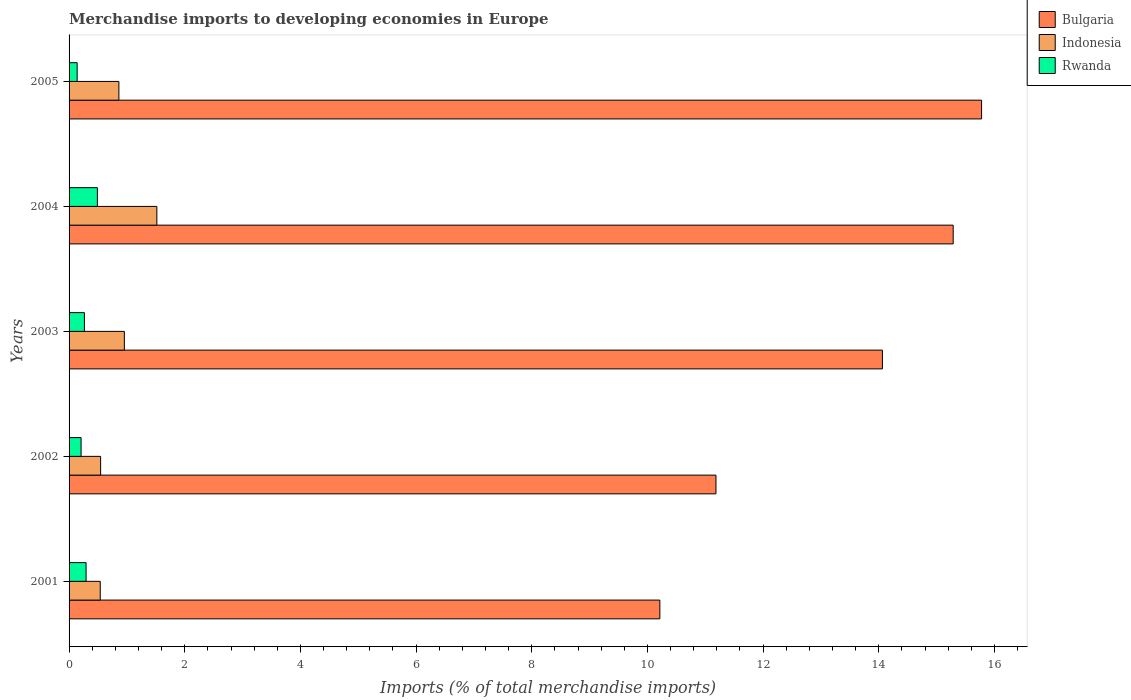How many groups of bars are there?
Your answer should be very brief. 5. Are the number of bars on each tick of the Y-axis equal?
Offer a very short reply. Yes. How many bars are there on the 2nd tick from the top?
Offer a very short reply. 3. What is the label of the 2nd group of bars from the top?
Your answer should be very brief. 2004. In how many cases, is the number of bars for a given year not equal to the number of legend labels?
Offer a very short reply. 0. What is the percentage total merchandise imports in Rwanda in 2001?
Make the answer very short. 0.29. Across all years, what is the maximum percentage total merchandise imports in Rwanda?
Keep it short and to the point. 0.49. Across all years, what is the minimum percentage total merchandise imports in Rwanda?
Provide a succinct answer. 0.14. In which year was the percentage total merchandise imports in Indonesia maximum?
Ensure brevity in your answer.  2004. What is the total percentage total merchandise imports in Rwanda in the graph?
Your response must be concise. 1.4. What is the difference between the percentage total merchandise imports in Bulgaria in 2003 and that in 2005?
Provide a succinct answer. -1.71. What is the difference between the percentage total merchandise imports in Rwanda in 2005 and the percentage total merchandise imports in Indonesia in 2001?
Ensure brevity in your answer.  -0.4. What is the average percentage total merchandise imports in Bulgaria per year?
Make the answer very short. 13.3. In the year 2005, what is the difference between the percentage total merchandise imports in Rwanda and percentage total merchandise imports in Bulgaria?
Keep it short and to the point. -15.64. In how many years, is the percentage total merchandise imports in Bulgaria greater than 4 %?
Offer a terse response. 5. What is the ratio of the percentage total merchandise imports in Bulgaria in 2003 to that in 2005?
Offer a terse response. 0.89. Is the percentage total merchandise imports in Indonesia in 2004 less than that in 2005?
Ensure brevity in your answer.  No. Is the difference between the percentage total merchandise imports in Rwanda in 2002 and 2005 greater than the difference between the percentage total merchandise imports in Bulgaria in 2002 and 2005?
Ensure brevity in your answer.  Yes. What is the difference between the highest and the second highest percentage total merchandise imports in Rwanda?
Your response must be concise. 0.2. What is the difference between the highest and the lowest percentage total merchandise imports in Bulgaria?
Ensure brevity in your answer.  5.56. What does the 2nd bar from the bottom in 2001 represents?
Make the answer very short. Indonesia. Is it the case that in every year, the sum of the percentage total merchandise imports in Rwanda and percentage total merchandise imports in Bulgaria is greater than the percentage total merchandise imports in Indonesia?
Offer a terse response. Yes. How many bars are there?
Offer a terse response. 15. Are all the bars in the graph horizontal?
Offer a terse response. Yes. Does the graph contain grids?
Provide a succinct answer. No. How many legend labels are there?
Ensure brevity in your answer.  3. What is the title of the graph?
Keep it short and to the point. Merchandise imports to developing economies in Europe. What is the label or title of the X-axis?
Keep it short and to the point. Imports (% of total merchandise imports). What is the Imports (% of total merchandise imports) of Bulgaria in 2001?
Keep it short and to the point. 10.21. What is the Imports (% of total merchandise imports) in Indonesia in 2001?
Your response must be concise. 0.54. What is the Imports (% of total merchandise imports) in Rwanda in 2001?
Offer a terse response. 0.29. What is the Imports (% of total merchandise imports) of Bulgaria in 2002?
Your answer should be compact. 11.18. What is the Imports (% of total merchandise imports) of Indonesia in 2002?
Your answer should be very brief. 0.55. What is the Imports (% of total merchandise imports) of Rwanda in 2002?
Keep it short and to the point. 0.21. What is the Imports (% of total merchandise imports) in Bulgaria in 2003?
Give a very brief answer. 14.06. What is the Imports (% of total merchandise imports) in Indonesia in 2003?
Offer a very short reply. 0.96. What is the Imports (% of total merchandise imports) in Rwanda in 2003?
Your answer should be compact. 0.27. What is the Imports (% of total merchandise imports) in Bulgaria in 2004?
Your answer should be compact. 15.29. What is the Imports (% of total merchandise imports) of Indonesia in 2004?
Keep it short and to the point. 1.52. What is the Imports (% of total merchandise imports) in Rwanda in 2004?
Offer a terse response. 0.49. What is the Imports (% of total merchandise imports) of Bulgaria in 2005?
Make the answer very short. 15.78. What is the Imports (% of total merchandise imports) in Indonesia in 2005?
Your answer should be very brief. 0.86. What is the Imports (% of total merchandise imports) in Rwanda in 2005?
Your answer should be very brief. 0.14. Across all years, what is the maximum Imports (% of total merchandise imports) in Bulgaria?
Provide a short and direct response. 15.78. Across all years, what is the maximum Imports (% of total merchandise imports) in Indonesia?
Give a very brief answer. 1.52. Across all years, what is the maximum Imports (% of total merchandise imports) of Rwanda?
Provide a short and direct response. 0.49. Across all years, what is the minimum Imports (% of total merchandise imports) in Bulgaria?
Provide a short and direct response. 10.21. Across all years, what is the minimum Imports (% of total merchandise imports) of Indonesia?
Offer a terse response. 0.54. Across all years, what is the minimum Imports (% of total merchandise imports) in Rwanda?
Provide a succinct answer. 0.14. What is the total Imports (% of total merchandise imports) of Bulgaria in the graph?
Provide a succinct answer. 66.52. What is the total Imports (% of total merchandise imports) in Indonesia in the graph?
Provide a succinct answer. 4.42. What is the total Imports (% of total merchandise imports) of Rwanda in the graph?
Give a very brief answer. 1.4. What is the difference between the Imports (% of total merchandise imports) in Bulgaria in 2001 and that in 2002?
Your answer should be very brief. -0.97. What is the difference between the Imports (% of total merchandise imports) of Indonesia in 2001 and that in 2002?
Give a very brief answer. -0.01. What is the difference between the Imports (% of total merchandise imports) in Rwanda in 2001 and that in 2002?
Keep it short and to the point. 0.09. What is the difference between the Imports (% of total merchandise imports) in Bulgaria in 2001 and that in 2003?
Give a very brief answer. -3.85. What is the difference between the Imports (% of total merchandise imports) in Indonesia in 2001 and that in 2003?
Ensure brevity in your answer.  -0.42. What is the difference between the Imports (% of total merchandise imports) of Rwanda in 2001 and that in 2003?
Provide a short and direct response. 0.03. What is the difference between the Imports (% of total merchandise imports) in Bulgaria in 2001 and that in 2004?
Provide a succinct answer. -5.07. What is the difference between the Imports (% of total merchandise imports) of Indonesia in 2001 and that in 2004?
Your answer should be compact. -0.98. What is the difference between the Imports (% of total merchandise imports) of Rwanda in 2001 and that in 2004?
Your response must be concise. -0.2. What is the difference between the Imports (% of total merchandise imports) in Bulgaria in 2001 and that in 2005?
Offer a very short reply. -5.56. What is the difference between the Imports (% of total merchandise imports) of Indonesia in 2001 and that in 2005?
Ensure brevity in your answer.  -0.32. What is the difference between the Imports (% of total merchandise imports) of Rwanda in 2001 and that in 2005?
Your answer should be compact. 0.15. What is the difference between the Imports (% of total merchandise imports) in Bulgaria in 2002 and that in 2003?
Keep it short and to the point. -2.88. What is the difference between the Imports (% of total merchandise imports) of Indonesia in 2002 and that in 2003?
Provide a succinct answer. -0.41. What is the difference between the Imports (% of total merchandise imports) in Rwanda in 2002 and that in 2003?
Give a very brief answer. -0.06. What is the difference between the Imports (% of total merchandise imports) in Bulgaria in 2002 and that in 2004?
Your answer should be compact. -4.1. What is the difference between the Imports (% of total merchandise imports) in Indonesia in 2002 and that in 2004?
Your response must be concise. -0.97. What is the difference between the Imports (% of total merchandise imports) of Rwanda in 2002 and that in 2004?
Offer a terse response. -0.28. What is the difference between the Imports (% of total merchandise imports) of Bulgaria in 2002 and that in 2005?
Your answer should be compact. -4.59. What is the difference between the Imports (% of total merchandise imports) of Indonesia in 2002 and that in 2005?
Make the answer very short. -0.32. What is the difference between the Imports (% of total merchandise imports) of Rwanda in 2002 and that in 2005?
Your answer should be compact. 0.07. What is the difference between the Imports (% of total merchandise imports) in Bulgaria in 2003 and that in 2004?
Ensure brevity in your answer.  -1.22. What is the difference between the Imports (% of total merchandise imports) of Indonesia in 2003 and that in 2004?
Make the answer very short. -0.56. What is the difference between the Imports (% of total merchandise imports) of Rwanda in 2003 and that in 2004?
Your answer should be compact. -0.22. What is the difference between the Imports (% of total merchandise imports) of Bulgaria in 2003 and that in 2005?
Provide a short and direct response. -1.71. What is the difference between the Imports (% of total merchandise imports) of Indonesia in 2003 and that in 2005?
Make the answer very short. 0.09. What is the difference between the Imports (% of total merchandise imports) in Rwanda in 2003 and that in 2005?
Offer a very short reply. 0.13. What is the difference between the Imports (% of total merchandise imports) of Bulgaria in 2004 and that in 2005?
Give a very brief answer. -0.49. What is the difference between the Imports (% of total merchandise imports) of Indonesia in 2004 and that in 2005?
Ensure brevity in your answer.  0.66. What is the difference between the Imports (% of total merchandise imports) in Rwanda in 2004 and that in 2005?
Keep it short and to the point. 0.35. What is the difference between the Imports (% of total merchandise imports) of Bulgaria in 2001 and the Imports (% of total merchandise imports) of Indonesia in 2002?
Keep it short and to the point. 9.67. What is the difference between the Imports (% of total merchandise imports) in Bulgaria in 2001 and the Imports (% of total merchandise imports) in Rwanda in 2002?
Ensure brevity in your answer.  10.01. What is the difference between the Imports (% of total merchandise imports) of Indonesia in 2001 and the Imports (% of total merchandise imports) of Rwanda in 2002?
Offer a very short reply. 0.33. What is the difference between the Imports (% of total merchandise imports) of Bulgaria in 2001 and the Imports (% of total merchandise imports) of Indonesia in 2003?
Ensure brevity in your answer.  9.26. What is the difference between the Imports (% of total merchandise imports) of Bulgaria in 2001 and the Imports (% of total merchandise imports) of Rwanda in 2003?
Keep it short and to the point. 9.95. What is the difference between the Imports (% of total merchandise imports) in Indonesia in 2001 and the Imports (% of total merchandise imports) in Rwanda in 2003?
Your answer should be compact. 0.27. What is the difference between the Imports (% of total merchandise imports) of Bulgaria in 2001 and the Imports (% of total merchandise imports) of Indonesia in 2004?
Your answer should be very brief. 8.7. What is the difference between the Imports (% of total merchandise imports) of Bulgaria in 2001 and the Imports (% of total merchandise imports) of Rwanda in 2004?
Provide a succinct answer. 9.72. What is the difference between the Imports (% of total merchandise imports) of Indonesia in 2001 and the Imports (% of total merchandise imports) of Rwanda in 2004?
Make the answer very short. 0.05. What is the difference between the Imports (% of total merchandise imports) of Bulgaria in 2001 and the Imports (% of total merchandise imports) of Indonesia in 2005?
Give a very brief answer. 9.35. What is the difference between the Imports (% of total merchandise imports) of Bulgaria in 2001 and the Imports (% of total merchandise imports) of Rwanda in 2005?
Your answer should be very brief. 10.07. What is the difference between the Imports (% of total merchandise imports) of Indonesia in 2001 and the Imports (% of total merchandise imports) of Rwanda in 2005?
Ensure brevity in your answer.  0.4. What is the difference between the Imports (% of total merchandise imports) in Bulgaria in 2002 and the Imports (% of total merchandise imports) in Indonesia in 2003?
Your answer should be very brief. 10.23. What is the difference between the Imports (% of total merchandise imports) of Bulgaria in 2002 and the Imports (% of total merchandise imports) of Rwanda in 2003?
Provide a succinct answer. 10.92. What is the difference between the Imports (% of total merchandise imports) in Indonesia in 2002 and the Imports (% of total merchandise imports) in Rwanda in 2003?
Your answer should be compact. 0.28. What is the difference between the Imports (% of total merchandise imports) of Bulgaria in 2002 and the Imports (% of total merchandise imports) of Indonesia in 2004?
Offer a terse response. 9.67. What is the difference between the Imports (% of total merchandise imports) in Bulgaria in 2002 and the Imports (% of total merchandise imports) in Rwanda in 2004?
Your answer should be compact. 10.7. What is the difference between the Imports (% of total merchandise imports) in Indonesia in 2002 and the Imports (% of total merchandise imports) in Rwanda in 2004?
Make the answer very short. 0.06. What is the difference between the Imports (% of total merchandise imports) in Bulgaria in 2002 and the Imports (% of total merchandise imports) in Indonesia in 2005?
Give a very brief answer. 10.32. What is the difference between the Imports (% of total merchandise imports) of Bulgaria in 2002 and the Imports (% of total merchandise imports) of Rwanda in 2005?
Your response must be concise. 11.04. What is the difference between the Imports (% of total merchandise imports) of Indonesia in 2002 and the Imports (% of total merchandise imports) of Rwanda in 2005?
Your answer should be very brief. 0.41. What is the difference between the Imports (% of total merchandise imports) of Bulgaria in 2003 and the Imports (% of total merchandise imports) of Indonesia in 2004?
Your answer should be compact. 12.54. What is the difference between the Imports (% of total merchandise imports) in Bulgaria in 2003 and the Imports (% of total merchandise imports) in Rwanda in 2004?
Ensure brevity in your answer.  13.57. What is the difference between the Imports (% of total merchandise imports) in Indonesia in 2003 and the Imports (% of total merchandise imports) in Rwanda in 2004?
Give a very brief answer. 0.47. What is the difference between the Imports (% of total merchandise imports) in Bulgaria in 2003 and the Imports (% of total merchandise imports) in Indonesia in 2005?
Provide a short and direct response. 13.2. What is the difference between the Imports (% of total merchandise imports) of Bulgaria in 2003 and the Imports (% of total merchandise imports) of Rwanda in 2005?
Your answer should be very brief. 13.92. What is the difference between the Imports (% of total merchandise imports) of Indonesia in 2003 and the Imports (% of total merchandise imports) of Rwanda in 2005?
Make the answer very short. 0.82. What is the difference between the Imports (% of total merchandise imports) of Bulgaria in 2004 and the Imports (% of total merchandise imports) of Indonesia in 2005?
Provide a short and direct response. 14.42. What is the difference between the Imports (% of total merchandise imports) of Bulgaria in 2004 and the Imports (% of total merchandise imports) of Rwanda in 2005?
Ensure brevity in your answer.  15.15. What is the difference between the Imports (% of total merchandise imports) of Indonesia in 2004 and the Imports (% of total merchandise imports) of Rwanda in 2005?
Keep it short and to the point. 1.38. What is the average Imports (% of total merchandise imports) in Bulgaria per year?
Your answer should be very brief. 13.3. What is the average Imports (% of total merchandise imports) in Indonesia per year?
Provide a short and direct response. 0.88. What is the average Imports (% of total merchandise imports) in Rwanda per year?
Your response must be concise. 0.28. In the year 2001, what is the difference between the Imports (% of total merchandise imports) in Bulgaria and Imports (% of total merchandise imports) in Indonesia?
Your answer should be very brief. 9.68. In the year 2001, what is the difference between the Imports (% of total merchandise imports) in Bulgaria and Imports (% of total merchandise imports) in Rwanda?
Offer a very short reply. 9.92. In the year 2001, what is the difference between the Imports (% of total merchandise imports) in Indonesia and Imports (% of total merchandise imports) in Rwanda?
Offer a terse response. 0.24. In the year 2002, what is the difference between the Imports (% of total merchandise imports) in Bulgaria and Imports (% of total merchandise imports) in Indonesia?
Ensure brevity in your answer.  10.64. In the year 2002, what is the difference between the Imports (% of total merchandise imports) of Bulgaria and Imports (% of total merchandise imports) of Rwanda?
Offer a terse response. 10.98. In the year 2002, what is the difference between the Imports (% of total merchandise imports) in Indonesia and Imports (% of total merchandise imports) in Rwanda?
Keep it short and to the point. 0.34. In the year 2003, what is the difference between the Imports (% of total merchandise imports) of Bulgaria and Imports (% of total merchandise imports) of Indonesia?
Keep it short and to the point. 13.11. In the year 2003, what is the difference between the Imports (% of total merchandise imports) of Bulgaria and Imports (% of total merchandise imports) of Rwanda?
Offer a terse response. 13.8. In the year 2003, what is the difference between the Imports (% of total merchandise imports) of Indonesia and Imports (% of total merchandise imports) of Rwanda?
Your answer should be compact. 0.69. In the year 2004, what is the difference between the Imports (% of total merchandise imports) in Bulgaria and Imports (% of total merchandise imports) in Indonesia?
Provide a short and direct response. 13.77. In the year 2004, what is the difference between the Imports (% of total merchandise imports) of Bulgaria and Imports (% of total merchandise imports) of Rwanda?
Offer a terse response. 14.8. In the year 2004, what is the difference between the Imports (% of total merchandise imports) in Indonesia and Imports (% of total merchandise imports) in Rwanda?
Your answer should be very brief. 1.03. In the year 2005, what is the difference between the Imports (% of total merchandise imports) in Bulgaria and Imports (% of total merchandise imports) in Indonesia?
Your answer should be compact. 14.92. In the year 2005, what is the difference between the Imports (% of total merchandise imports) in Bulgaria and Imports (% of total merchandise imports) in Rwanda?
Provide a short and direct response. 15.64. In the year 2005, what is the difference between the Imports (% of total merchandise imports) in Indonesia and Imports (% of total merchandise imports) in Rwanda?
Your answer should be compact. 0.72. What is the ratio of the Imports (% of total merchandise imports) of Bulgaria in 2001 to that in 2002?
Offer a very short reply. 0.91. What is the ratio of the Imports (% of total merchandise imports) of Indonesia in 2001 to that in 2002?
Provide a short and direct response. 0.99. What is the ratio of the Imports (% of total merchandise imports) of Rwanda in 2001 to that in 2002?
Your response must be concise. 1.42. What is the ratio of the Imports (% of total merchandise imports) in Bulgaria in 2001 to that in 2003?
Provide a short and direct response. 0.73. What is the ratio of the Imports (% of total merchandise imports) of Indonesia in 2001 to that in 2003?
Offer a very short reply. 0.56. What is the ratio of the Imports (% of total merchandise imports) of Rwanda in 2001 to that in 2003?
Your answer should be very brief. 1.11. What is the ratio of the Imports (% of total merchandise imports) of Bulgaria in 2001 to that in 2004?
Your answer should be very brief. 0.67. What is the ratio of the Imports (% of total merchandise imports) of Indonesia in 2001 to that in 2004?
Provide a short and direct response. 0.36. What is the ratio of the Imports (% of total merchandise imports) in Rwanda in 2001 to that in 2004?
Ensure brevity in your answer.  0.6. What is the ratio of the Imports (% of total merchandise imports) in Bulgaria in 2001 to that in 2005?
Your answer should be very brief. 0.65. What is the ratio of the Imports (% of total merchandise imports) of Indonesia in 2001 to that in 2005?
Your answer should be very brief. 0.63. What is the ratio of the Imports (% of total merchandise imports) in Rwanda in 2001 to that in 2005?
Provide a short and direct response. 2.1. What is the ratio of the Imports (% of total merchandise imports) in Bulgaria in 2002 to that in 2003?
Give a very brief answer. 0.8. What is the ratio of the Imports (% of total merchandise imports) in Indonesia in 2002 to that in 2003?
Make the answer very short. 0.57. What is the ratio of the Imports (% of total merchandise imports) in Rwanda in 2002 to that in 2003?
Give a very brief answer. 0.78. What is the ratio of the Imports (% of total merchandise imports) of Bulgaria in 2002 to that in 2004?
Ensure brevity in your answer.  0.73. What is the ratio of the Imports (% of total merchandise imports) of Indonesia in 2002 to that in 2004?
Your response must be concise. 0.36. What is the ratio of the Imports (% of total merchandise imports) in Rwanda in 2002 to that in 2004?
Offer a very short reply. 0.42. What is the ratio of the Imports (% of total merchandise imports) of Bulgaria in 2002 to that in 2005?
Offer a very short reply. 0.71. What is the ratio of the Imports (% of total merchandise imports) of Indonesia in 2002 to that in 2005?
Offer a very short reply. 0.63. What is the ratio of the Imports (% of total merchandise imports) in Rwanda in 2002 to that in 2005?
Provide a succinct answer. 1.48. What is the ratio of the Imports (% of total merchandise imports) in Bulgaria in 2003 to that in 2004?
Offer a terse response. 0.92. What is the ratio of the Imports (% of total merchandise imports) of Indonesia in 2003 to that in 2004?
Keep it short and to the point. 0.63. What is the ratio of the Imports (% of total merchandise imports) in Rwanda in 2003 to that in 2004?
Provide a succinct answer. 0.54. What is the ratio of the Imports (% of total merchandise imports) in Bulgaria in 2003 to that in 2005?
Offer a very short reply. 0.89. What is the ratio of the Imports (% of total merchandise imports) of Indonesia in 2003 to that in 2005?
Offer a very short reply. 1.11. What is the ratio of the Imports (% of total merchandise imports) in Rwanda in 2003 to that in 2005?
Provide a succinct answer. 1.9. What is the ratio of the Imports (% of total merchandise imports) of Bulgaria in 2004 to that in 2005?
Your answer should be compact. 0.97. What is the ratio of the Imports (% of total merchandise imports) in Indonesia in 2004 to that in 2005?
Offer a very short reply. 1.76. What is the ratio of the Imports (% of total merchandise imports) in Rwanda in 2004 to that in 2005?
Provide a short and direct response. 3.5. What is the difference between the highest and the second highest Imports (% of total merchandise imports) of Bulgaria?
Make the answer very short. 0.49. What is the difference between the highest and the second highest Imports (% of total merchandise imports) of Indonesia?
Your response must be concise. 0.56. What is the difference between the highest and the second highest Imports (% of total merchandise imports) of Rwanda?
Give a very brief answer. 0.2. What is the difference between the highest and the lowest Imports (% of total merchandise imports) of Bulgaria?
Keep it short and to the point. 5.56. What is the difference between the highest and the lowest Imports (% of total merchandise imports) in Indonesia?
Make the answer very short. 0.98. What is the difference between the highest and the lowest Imports (% of total merchandise imports) in Rwanda?
Ensure brevity in your answer.  0.35. 